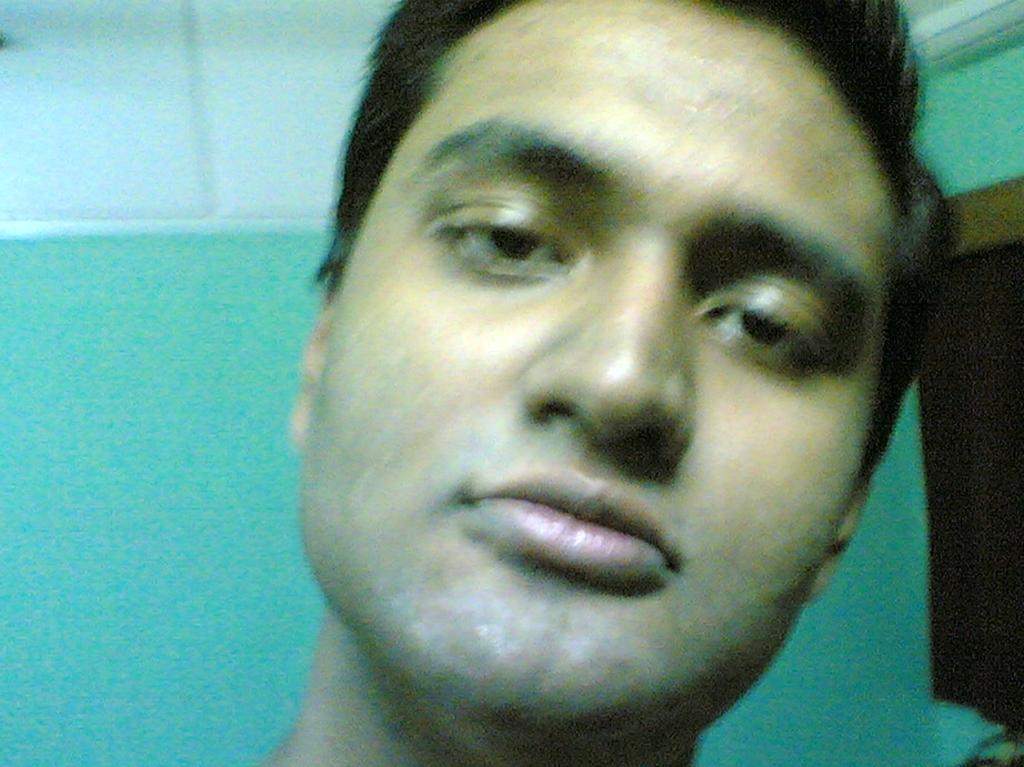Can you describe this image briefly? In the center of the image, we can see a person's face and in the background, there is a wall. 